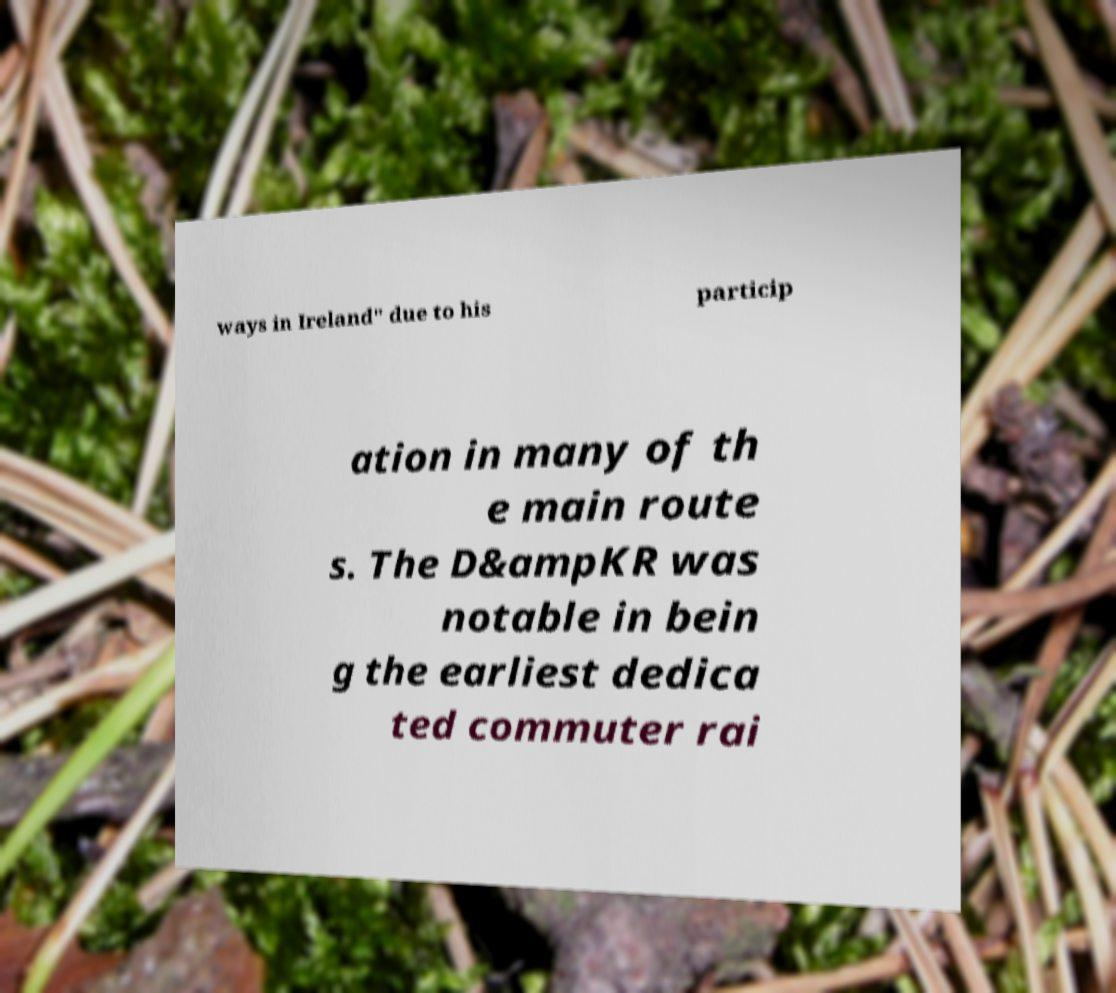Can you read and provide the text displayed in the image?This photo seems to have some interesting text. Can you extract and type it out for me? ways in Ireland" due to his particip ation in many of th e main route s. The D&ampKR was notable in bein g the earliest dedica ted commuter rai 